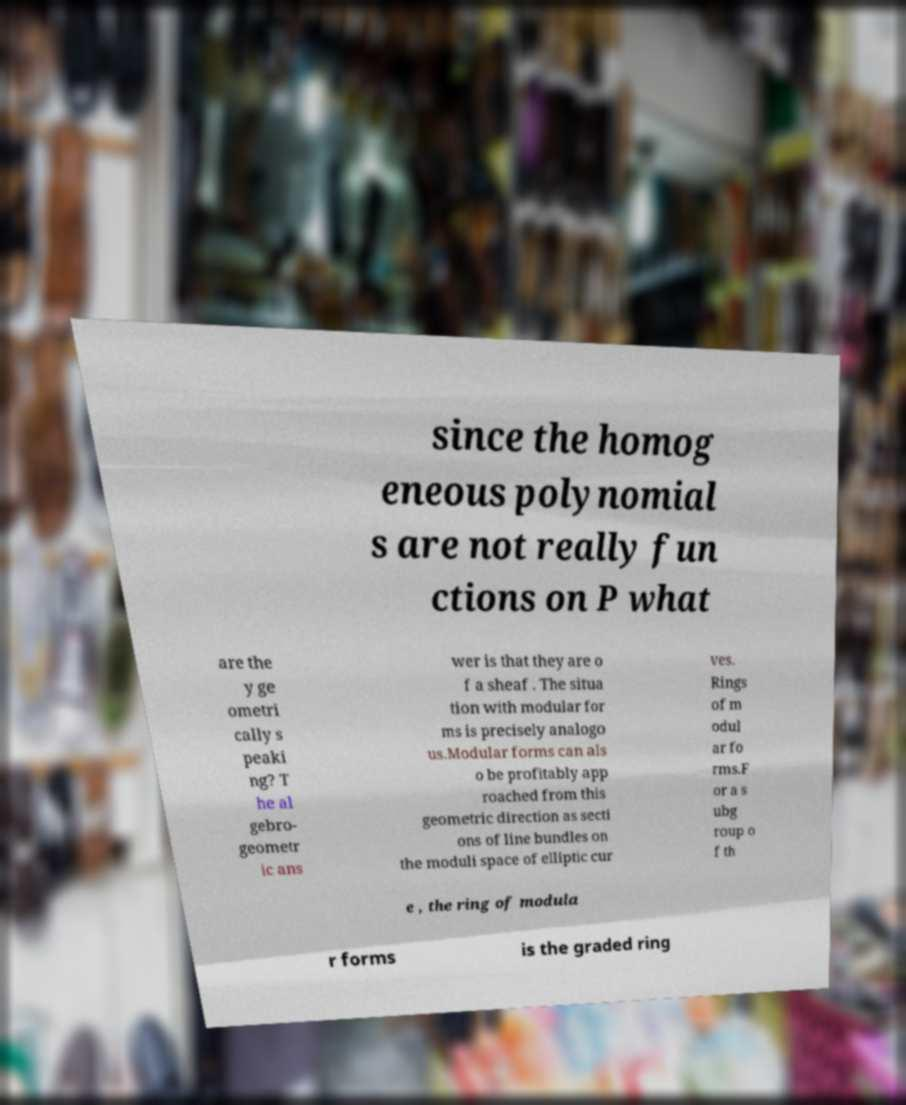What messages or text are displayed in this image? I need them in a readable, typed format. since the homog eneous polynomial s are not really fun ctions on P what are the y ge ometri cally s peaki ng? T he al gebro- geometr ic ans wer is that they are o f a sheaf . The situa tion with modular for ms is precisely analogo us.Modular forms can als o be profitably app roached from this geometric direction as secti ons of line bundles on the moduli space of elliptic cur ves. Rings of m odul ar fo rms.F or a s ubg roup o f th e , the ring of modula r forms is the graded ring 